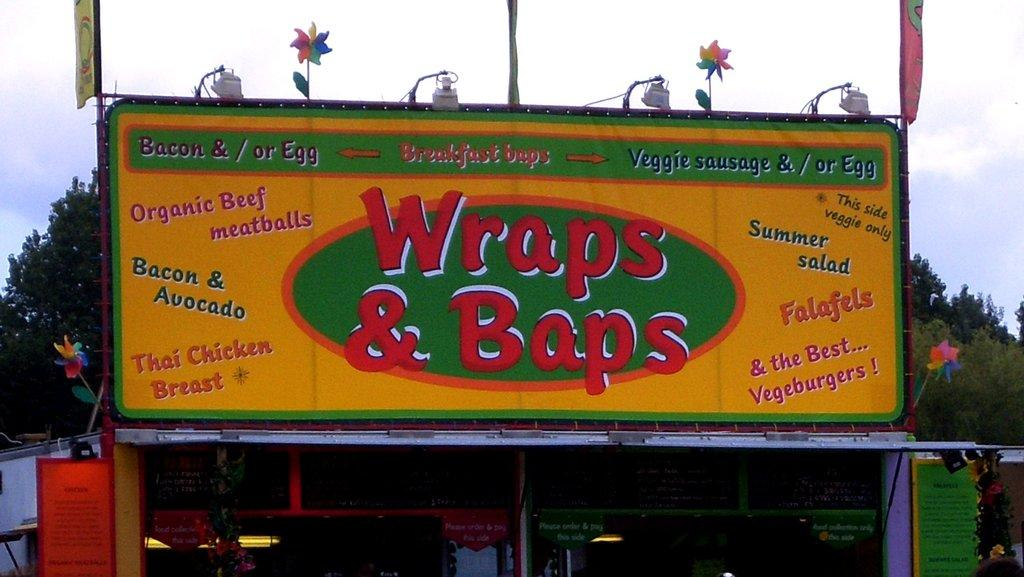<image>
Give a short and clear explanation of the subsequent image. Wrap and Baps has advertisement stating what they sell to their customers. 